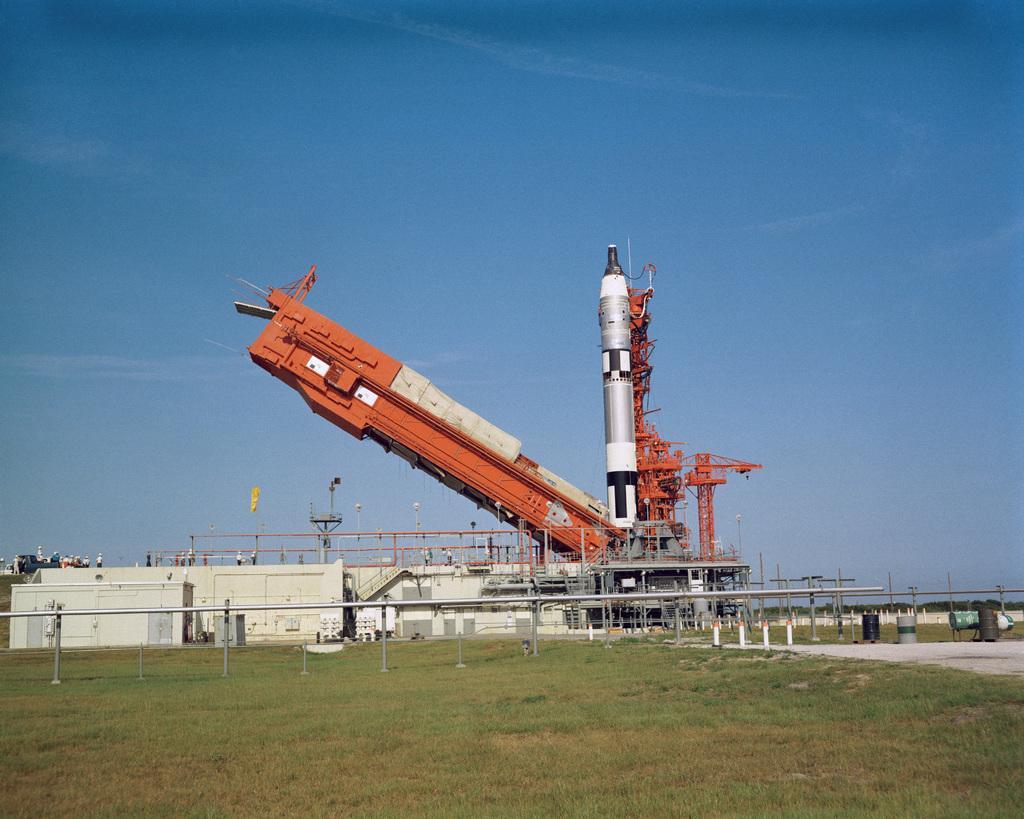Please provide a concise description of this image. This picture shows a building and we see a rocket to the launching pad and we see water and grass on the ground and we see a flag and a blue sky. 